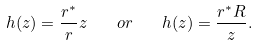Convert formula to latex. <formula><loc_0><loc_0><loc_500><loc_500>h ( z ) = \frac { r ^ { \ast } } { r } z \quad o r \quad h ( z ) = \frac { r ^ { \ast } R } { z } .</formula> 